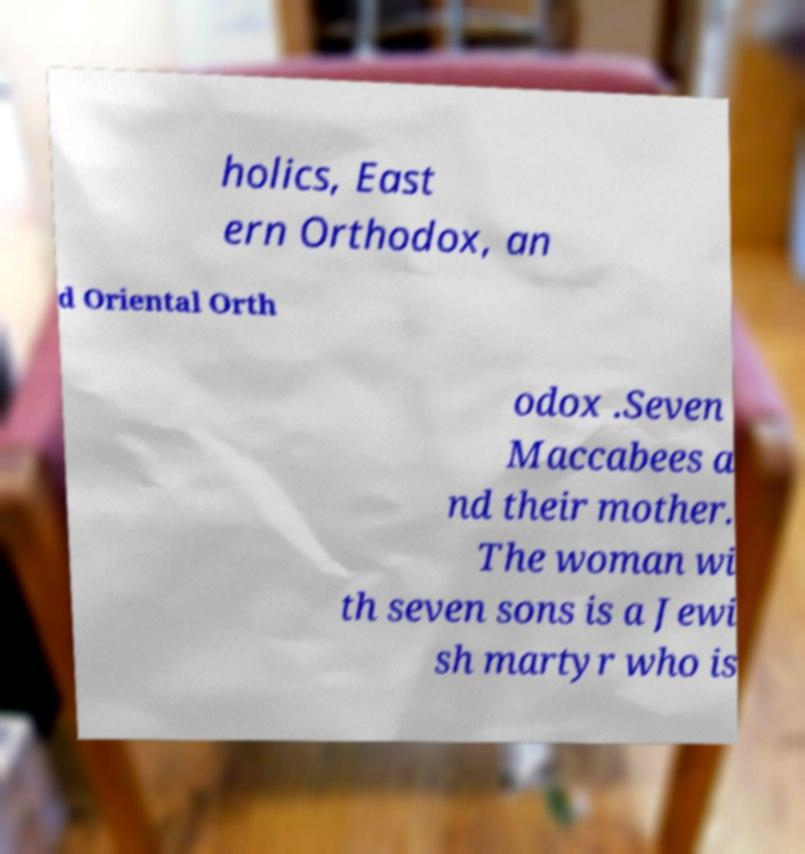Could you extract and type out the text from this image? holics, East ern Orthodox, an d Oriental Orth odox .Seven Maccabees a nd their mother. The woman wi th seven sons is a Jewi sh martyr who is 